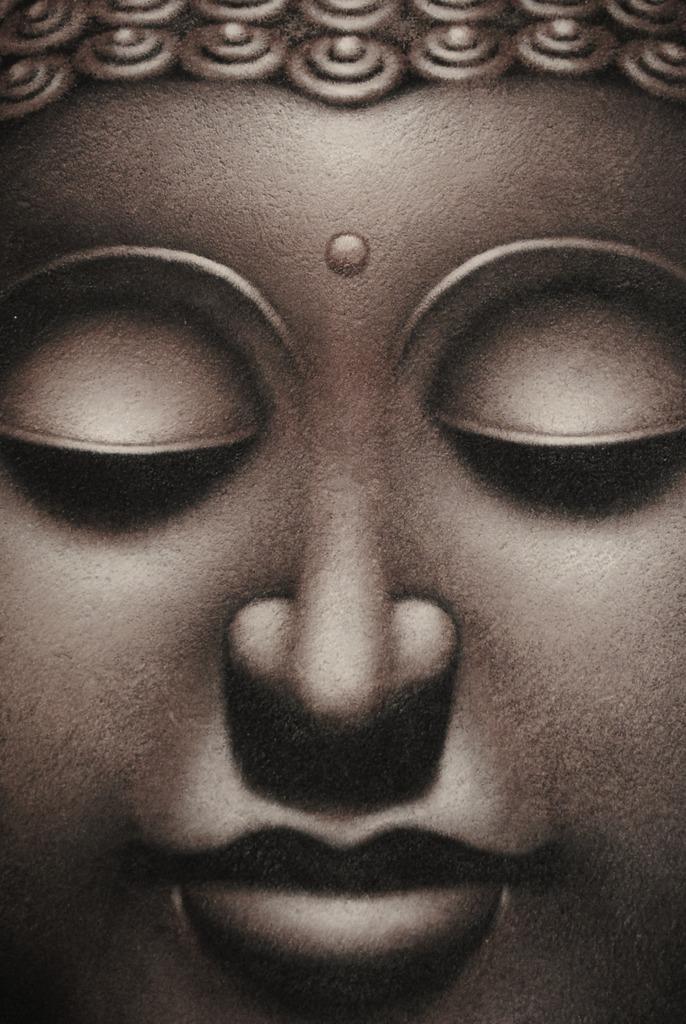Can you describe this image briefly? This is an image of a person's statue. In which, we can see there are eyes closed, there is a nose, a mouth and cheeks. 